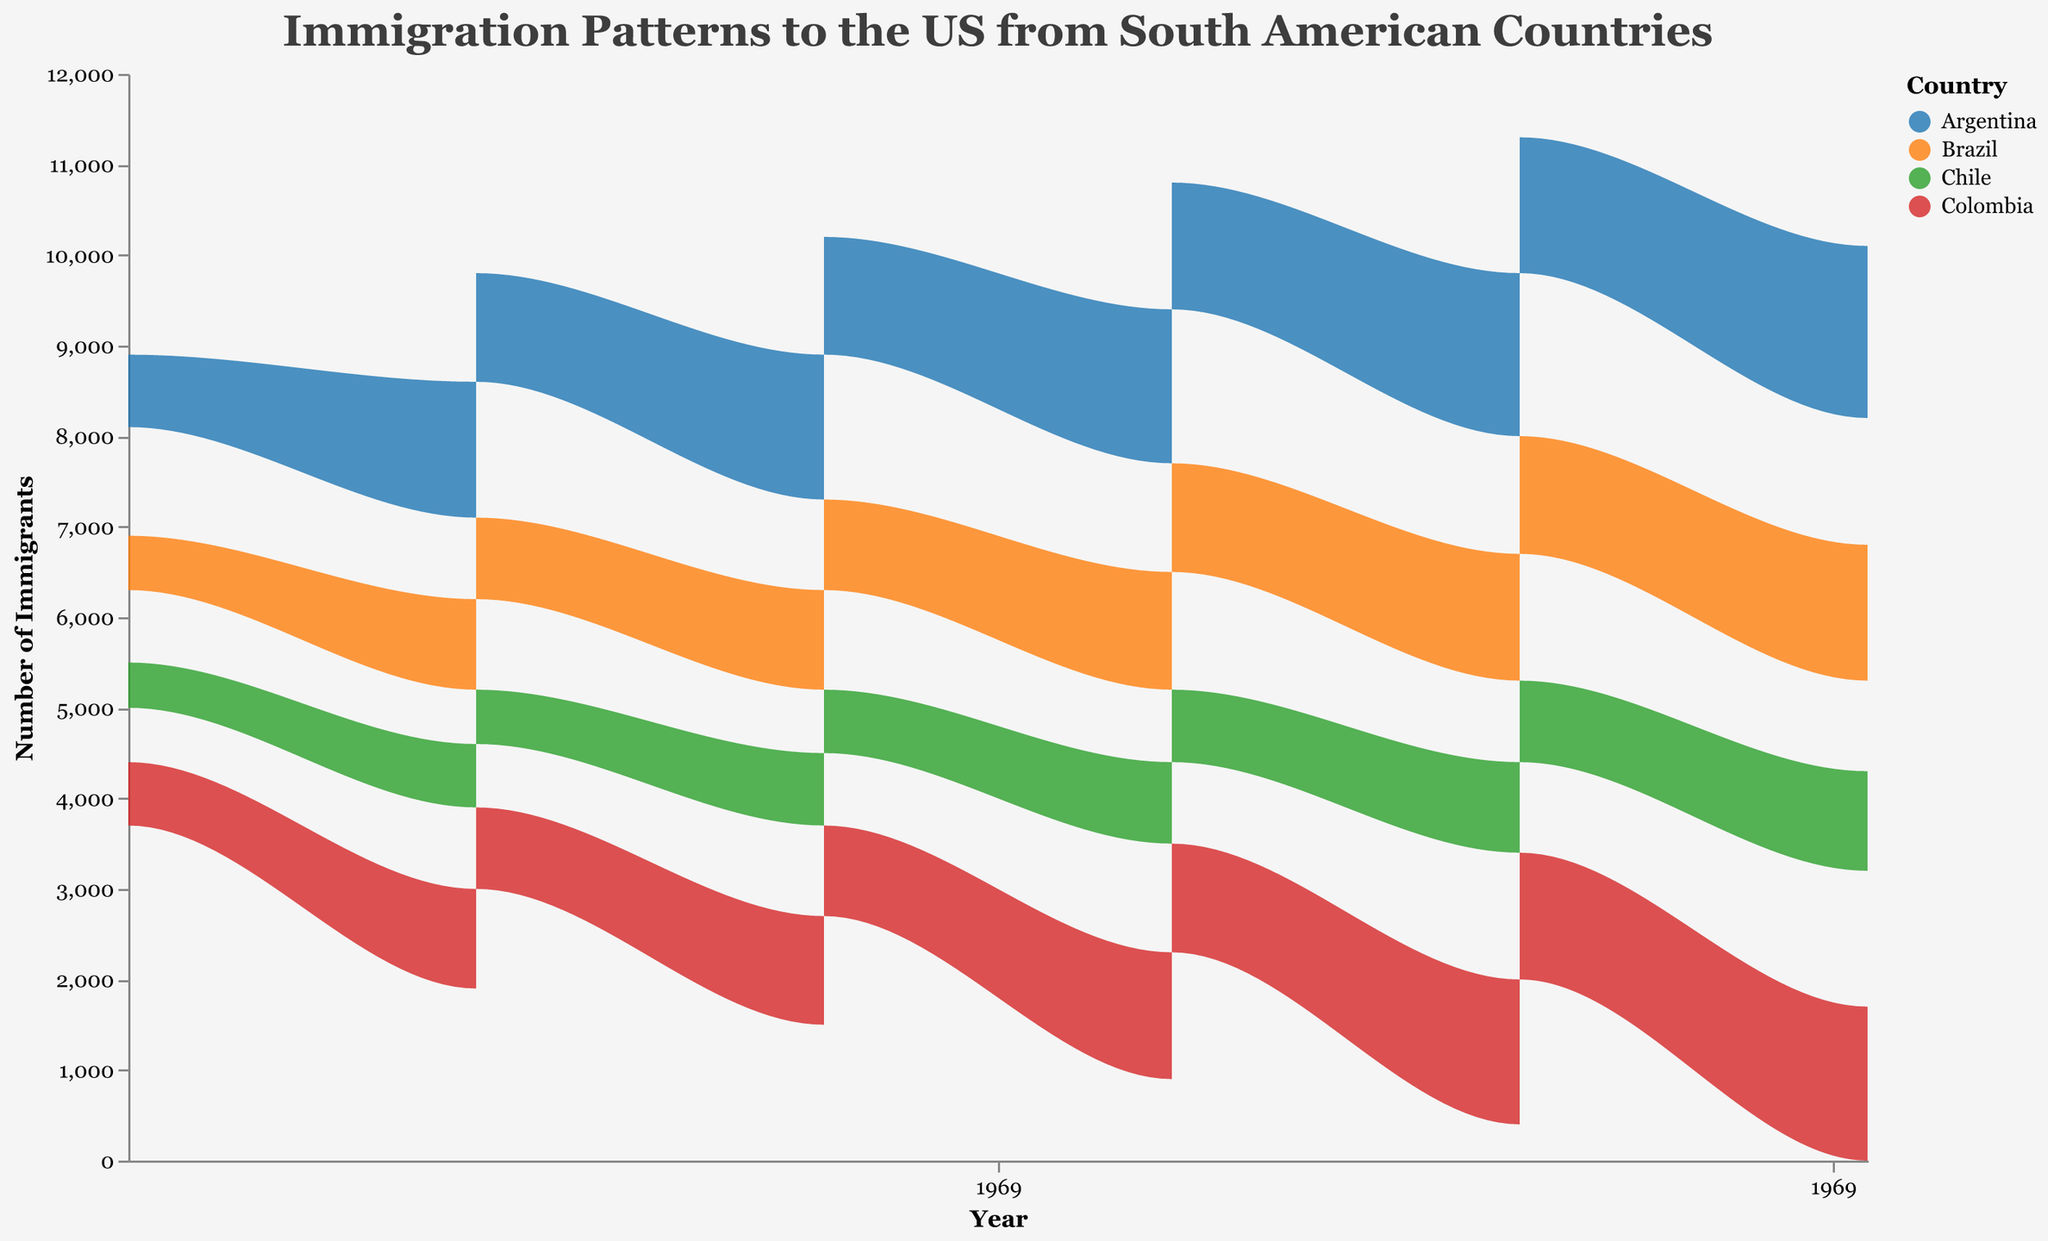How many distinct age groups are present in the graph? By looking at the color legend and tooltips in the graph, we can see the distinct age groups. Overall, there are two distinct age groups: 18-25 and 26-35.
Answer: 2 Which country has the highest number of immigrants in 2023 within the 18-25 age group? Observe the peaks for each country in the 2023 section, and focus on the color for the 18-25 age group. Argentina’s value reaches 1900, which is the highest.
Answer: Argentina What’s the trend in immigration numbers from Argentina for 18-25 age group from 1973 to 2023? Observe the areas corresponding to Argentina (specific color for the country) and look at the height of the 18-25 age group over the years. The trend shows a consistent increase every decade from 1200 in 1973 to 1900 in 2023.
Answer: Increasing Compare the number of 26-35 age group immigrants with College education from Brazil in 1983 and 2023. Which year had more immigrants? This requires checking the specific values in those years for Brazil for the 26-35 age group with College education. In 1983, the value is 900, and in 2023, it is 1400. Therefore, 2023 had more immigrants.
Answer: 2023 What is common among all the countries’ immigration patterns in terms of age groups? Observe and compare the immigration patterns for all countries by focusing on age groups. All countries show that both 18-25 and 26-35 age groups have increased over the 50-year period.
Answer: Increased How many immigrants from Colombia were in the 26-35 age group with College education in 2003? By looking at the data tooltip in the year 2003 for Colombia for the specified group, the number is 1200.
Answer: 1200 Which country had the lowest number of immigrants in 1973 for the 26-35 age group with College education? By investigating the lowest tip of the area chart for this group in 1973, Chile had the lowest number, which is 500.
Answer: Chile Calculate the total number of immigrants from Argentina over the 50 years for the 26-35 age group with College education. Sum the number of immigrants from the given data: 800 (1973) + 1200 (1983) + 1300 (1993) + 1400 (2003) + 1500 (2013) + 1600 (2023) = 7800.
Answer: 7800 What can be inferred about the educational level of immigrants between the 18-25 and 26-35 age groups in Chile in 2023? By comparing both age groups in Chile in 2023, 18-25 have High-School level (1100) and 26-35 have College level (1000). It can be inferred that the difference in educational levels is minor.
Answer: Minor difference How did immigration from Brazil in the 18-25 age group with High-School education change from 1973 to 2023? Examine the area representing Brazil’s 18-25 age group for High-School graduates from 1973 to 2023. The value increased from 800 in 1973 to 1500 in 2023, indicating a steady increase.
Answer: Steady increase 